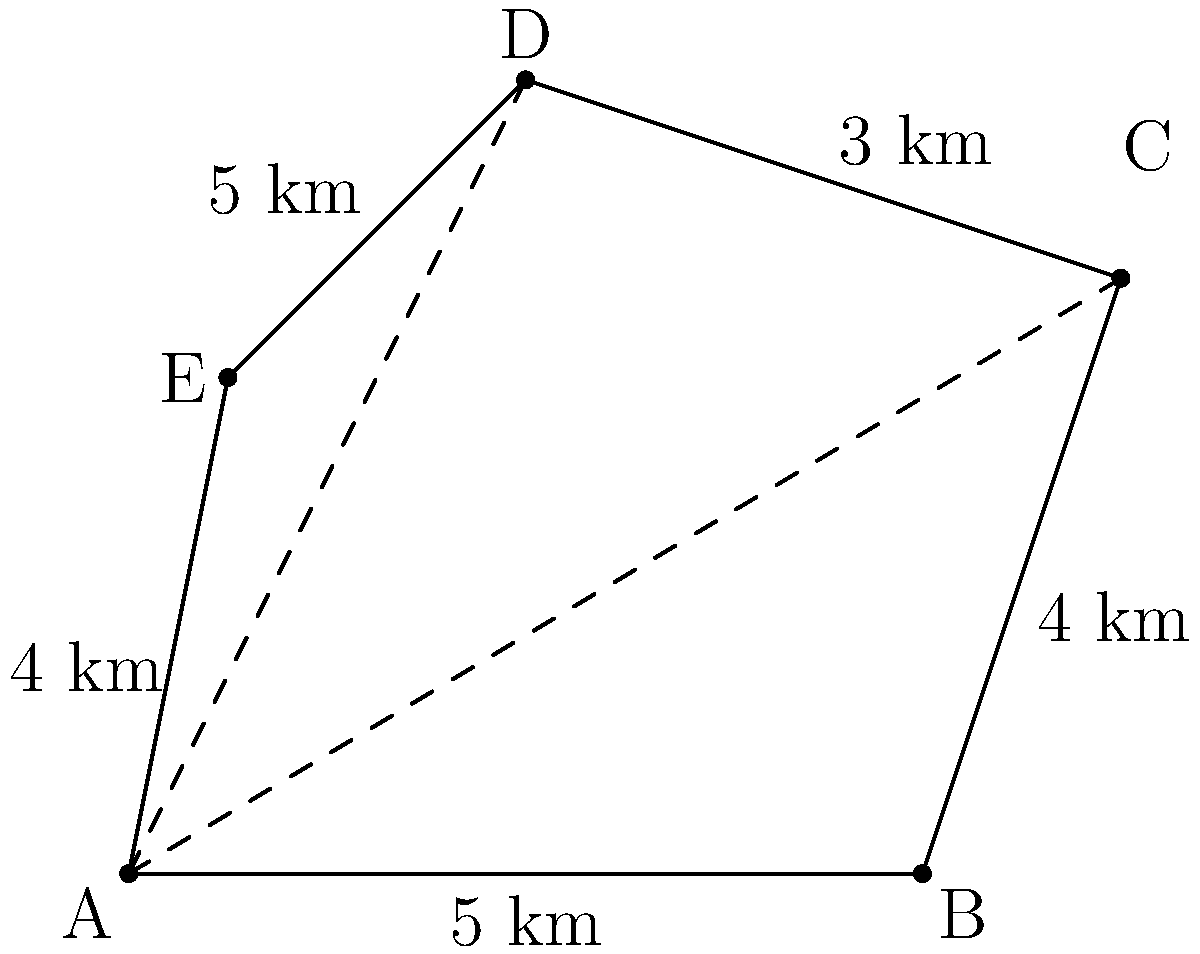Your newly acquired private island has an irregular pentagonal shape. To calculate its area, you decide to use triangulation. The lengths of the sides are: AB = 5 km, BC = 4 km, CD = 3 km, DE = 5 km, and EA = 4 km. If the diagonal AC is 10 km and AD is 9 km, what is the total area of your island in square kilometers? To solve this problem, we'll use triangulation to divide the pentagon into three triangles: ABC, ACD, and ADE. We'll then calculate the area of each triangle using Heron's formula and sum them up.

Heron's formula: $A = \sqrt{s(s-a)(s-b)(s-c)}$, where $s = \frac{a+b+c}{2}$ (semi-perimeter)

1. Triangle ABC:
   $a = 5$, $b = 4$, $c = 10$
   $s = \frac{5+4+10}{2} = 9.5$
   $A_{ABC} = \sqrt{9.5(9.5-5)(9.5-4)(9.5-10)} = \sqrt{9.5 \cdot 4.5 \cdot 5.5 \cdot (-0.5)} = 10$ km²

2. Triangle ACD:
   $a = 10$, $b = 3$, $c = 9$
   $s = \frac{10+3+9}{2} = 11$
   $A_{ACD} = \sqrt{11(11-10)(11-3)(11-9)} = \sqrt{11 \cdot 1 \cdot 8 \cdot 2} = \sqrt{176} = 13.27$ km²

3. Triangle ADE:
   $a = 9$, $b = 5$, $c = 4$
   $s = \frac{9+5+4}{2} = 9$
   $A_{ADE} = \sqrt{9(9-9)(9-5)(9-4)} = \sqrt{9 \cdot 0 \cdot 4 \cdot 5} = 0$ km²

Total area = $A_{ABC} + A_{ACD} + A_{ADE} = 10 + 13.27 + 0 = 23.27$ km²
Answer: 23.27 km² 